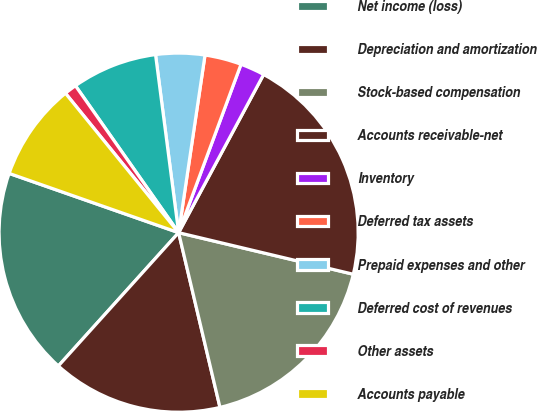Convert chart. <chart><loc_0><loc_0><loc_500><loc_500><pie_chart><fcel>Net income (loss)<fcel>Depreciation and amortization<fcel>Stock-based compensation<fcel>Accounts receivable-net<fcel>Inventory<fcel>Deferred tax assets<fcel>Prepaid expenses and other<fcel>Deferred cost of revenues<fcel>Other assets<fcel>Accounts payable<nl><fcel>18.67%<fcel>15.38%<fcel>17.58%<fcel>20.87%<fcel>2.2%<fcel>3.3%<fcel>4.4%<fcel>7.69%<fcel>1.11%<fcel>8.79%<nl></chart> 